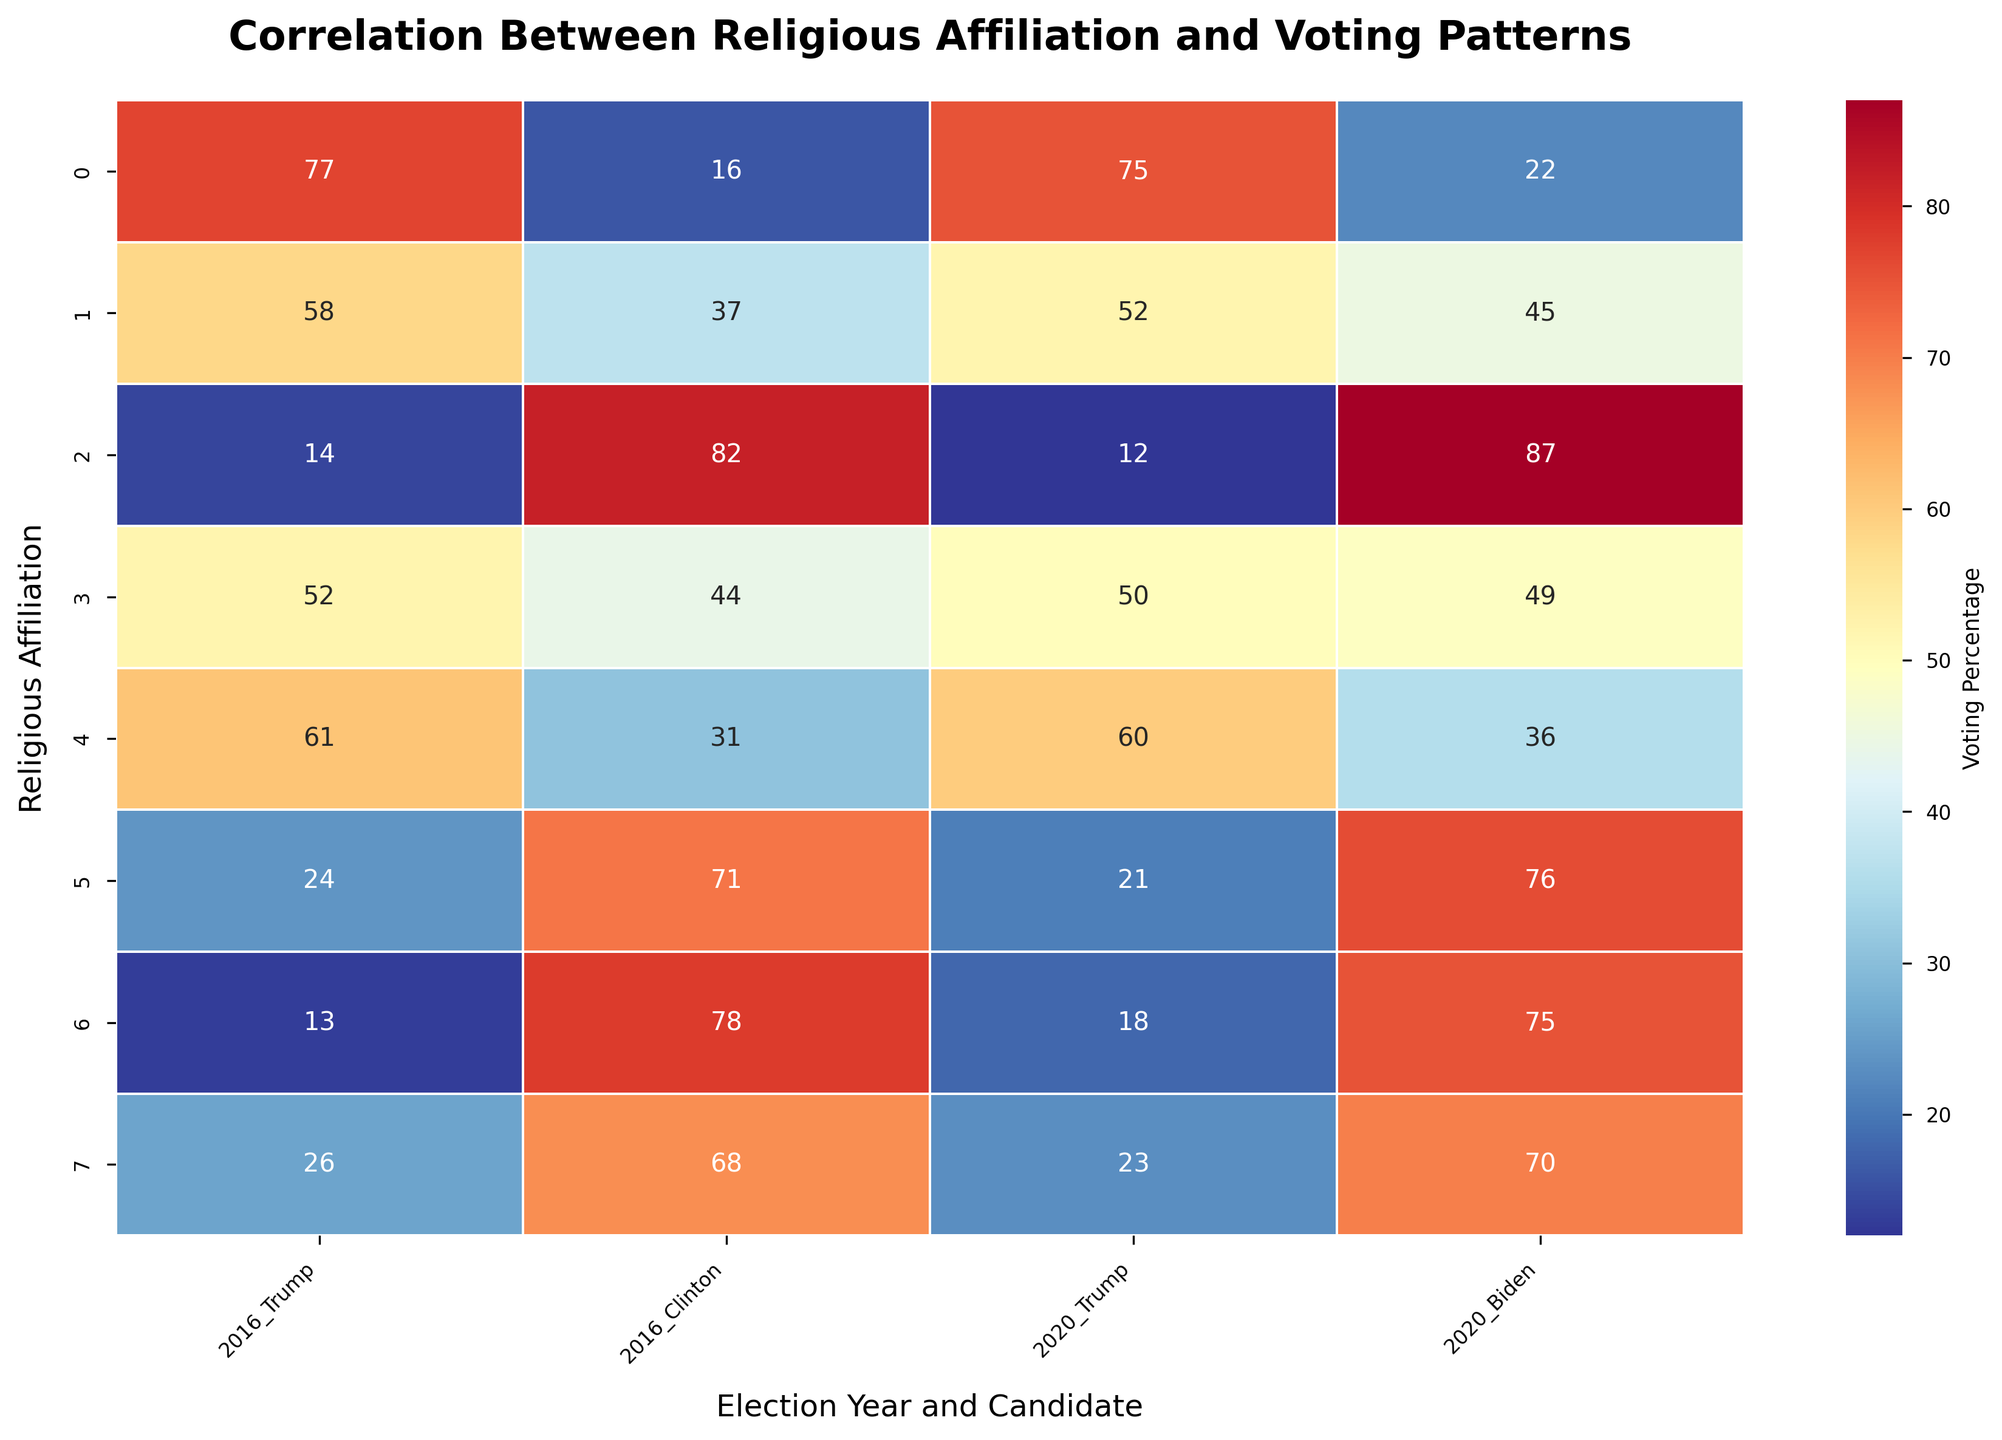What does the heatmap's title indicate? The heatmap title, "Correlation Between Religious Affiliation and Voting Patterns," suggests that the map shows how different religious groups voted for Trump or Clinton in 2016, and Trump or Biden in 2020.
Answer: It indicates the topic of the heatmap Which religious group had the highest percentage of votes for Trump in 2016? By examining the heatmap, the Evangelical Protestant group shows the highest percentage of votes for Trump in 2016 with 77%.
Answer: Evangelical Protestant What is the percentage difference between Jewish votes for Clinton in 2016 and for Biden in 2020? Jewish voters had 71% for Clinton in 2016 and 76% for Biden in 2020. The difference is 76% - 71% = 5%.
Answer: 5% Which candidate received more votes from the Unaffiliated group in 2020? From the heatmap, Biden received 70% of the vote from the Unaffiliated group in 2020, compared to Trump's 23%.
Answer: Biden How do the voting patterns of Historically Black Protestants compare between 2016 and 2020? Historically Black Protestants voted 82% for Clinton and 87% for Biden, showing an increase of 5% for the Democratic candidate. Votes for Trump slightly decreased from 14% in 2016 to 12% in 2020.
Answer: Biden saw an increase; Trump saw a decrease What's the sum of the votes for Trump in 2020 across all religious groups? Add the percentages: 75 (Evangelical Protestant) + 52 (Mainline Protestant) + 12 (Historically Black Protestant) + 50 (Catholic) + 60 (Mormon) + 21 (Jewish) + 18 (Muslim) + 23 (Unaffiliated) = 311%.
Answer: 311% Which religious affiliation showed almost no change in their voting pattern for Trump between 2016 and 2020? Evangelicals showed minimal change, only decreasing from 77% in 2016 to 75% in 2020.
Answer: Evangelical Protestant For the Mainline Protestant group, how does their support for Clinton in 2016 compare to their support for Biden in 2020? Mainline Protestants showed 37% support for Clinton in 2016 and 45% for Biden in 2020, indicating an increase by 8%.
Answer: Increased support for Biden by 8% Is the heatmap indicating a stronger preference for Democratic or Republican candidates in the Jewish community? The heatmap shows Jewish voters have a stronger preference for Democratic candidates, with 71% for Clinton and 76% for Biden, compared to 24% for Trump in 2016 and 21% in 2020.
Answer: Democratic candidates 